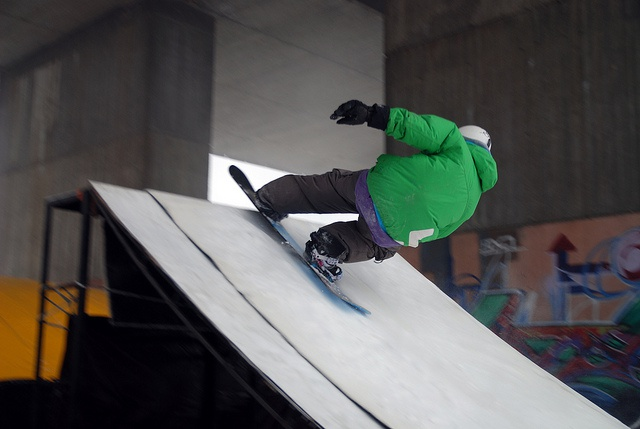Describe the objects in this image and their specific colors. I can see people in black, green, and darkgreen tones and snowboard in black, darkgray, and gray tones in this image. 